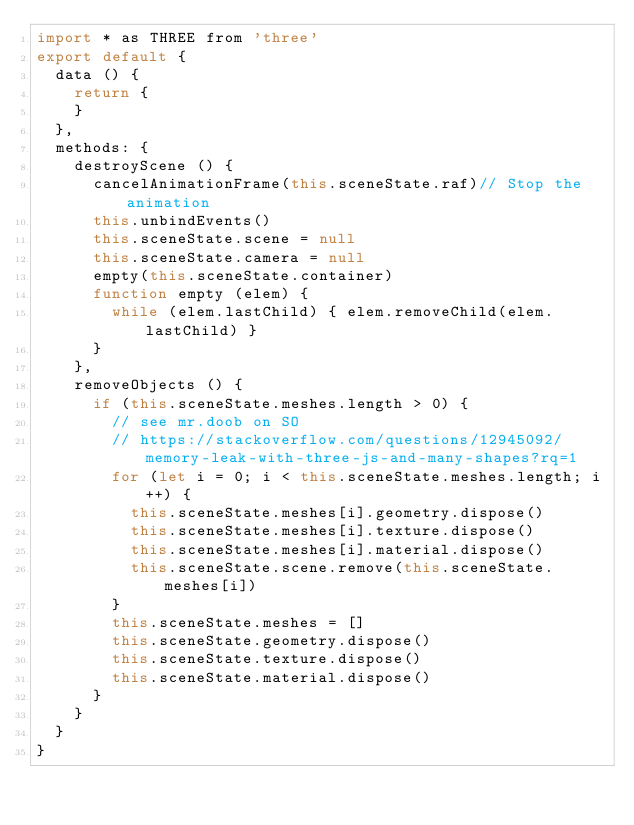Convert code to text. <code><loc_0><loc_0><loc_500><loc_500><_JavaScript_>import * as THREE from 'three'
export default {
  data () {
    return {
    }
  },
  methods: {
    destroyScene () {
      cancelAnimationFrame(this.sceneState.raf)// Stop the animation
      this.unbindEvents()
      this.sceneState.scene = null
      this.sceneState.camera = null
      empty(this.sceneState.container)
      function empty (elem) {
        while (elem.lastChild) { elem.removeChild(elem.lastChild) }
      }
    },
    removeObjects () {
      if (this.sceneState.meshes.length > 0) {
        // see mr.doob on SO
        // https://stackoverflow.com/questions/12945092/memory-leak-with-three-js-and-many-shapes?rq=1
        for (let i = 0; i < this.sceneState.meshes.length; i++) {
          this.sceneState.meshes[i].geometry.dispose()
          this.sceneState.meshes[i].texture.dispose()
          this.sceneState.meshes[i].material.dispose()
          this.sceneState.scene.remove(this.sceneState.meshes[i])
        }
        this.sceneState.meshes = []
        this.sceneState.geometry.dispose()
        this.sceneState.texture.dispose()
        this.sceneState.material.dispose()
      }
    }
  }
}
</code> 